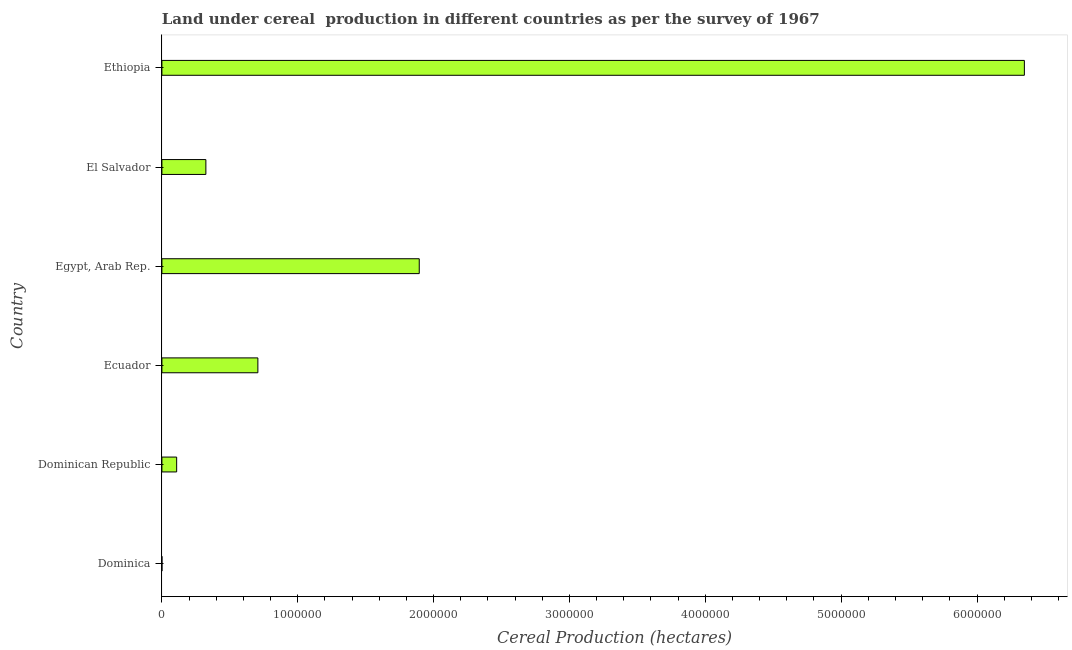What is the title of the graph?
Your answer should be compact. Land under cereal  production in different countries as per the survey of 1967. What is the label or title of the X-axis?
Offer a terse response. Cereal Production (hectares). What is the label or title of the Y-axis?
Make the answer very short. Country. What is the land under cereal production in Ethiopia?
Your response must be concise. 6.35e+06. Across all countries, what is the maximum land under cereal production?
Ensure brevity in your answer.  6.35e+06. Across all countries, what is the minimum land under cereal production?
Provide a short and direct response. 125. In which country was the land under cereal production maximum?
Offer a terse response. Ethiopia. In which country was the land under cereal production minimum?
Your answer should be very brief. Dominica. What is the sum of the land under cereal production?
Provide a succinct answer. 9.38e+06. What is the difference between the land under cereal production in Dominican Republic and El Salvador?
Ensure brevity in your answer.  -2.15e+05. What is the average land under cereal production per country?
Ensure brevity in your answer.  1.56e+06. What is the median land under cereal production?
Give a very brief answer. 5.15e+05. In how many countries, is the land under cereal production greater than 1400000 hectares?
Give a very brief answer. 2. What is the ratio of the land under cereal production in Dominica to that in Ethiopia?
Provide a succinct answer. 0. What is the difference between the highest and the second highest land under cereal production?
Keep it short and to the point. 4.45e+06. What is the difference between the highest and the lowest land under cereal production?
Your answer should be compact. 6.35e+06. In how many countries, is the land under cereal production greater than the average land under cereal production taken over all countries?
Provide a succinct answer. 2. Are all the bars in the graph horizontal?
Your answer should be very brief. Yes. What is the difference between two consecutive major ticks on the X-axis?
Provide a succinct answer. 1.00e+06. What is the Cereal Production (hectares) in Dominica?
Your answer should be very brief. 125. What is the Cereal Production (hectares) of Dominican Republic?
Offer a terse response. 1.09e+05. What is the Cereal Production (hectares) of Ecuador?
Keep it short and to the point. 7.06e+05. What is the Cereal Production (hectares) of Egypt, Arab Rep.?
Make the answer very short. 1.89e+06. What is the Cereal Production (hectares) in El Salvador?
Ensure brevity in your answer.  3.24e+05. What is the Cereal Production (hectares) in Ethiopia?
Provide a short and direct response. 6.35e+06. What is the difference between the Cereal Production (hectares) in Dominica and Dominican Republic?
Provide a short and direct response. -1.08e+05. What is the difference between the Cereal Production (hectares) in Dominica and Ecuador?
Your response must be concise. -7.06e+05. What is the difference between the Cereal Production (hectares) in Dominica and Egypt, Arab Rep.?
Ensure brevity in your answer.  -1.89e+06. What is the difference between the Cereal Production (hectares) in Dominica and El Salvador?
Make the answer very short. -3.24e+05. What is the difference between the Cereal Production (hectares) in Dominica and Ethiopia?
Give a very brief answer. -6.35e+06. What is the difference between the Cereal Production (hectares) in Dominican Republic and Ecuador?
Offer a very short reply. -5.98e+05. What is the difference between the Cereal Production (hectares) in Dominican Republic and Egypt, Arab Rep.?
Your answer should be compact. -1.79e+06. What is the difference between the Cereal Production (hectares) in Dominican Republic and El Salvador?
Provide a short and direct response. -2.15e+05. What is the difference between the Cereal Production (hectares) in Dominican Republic and Ethiopia?
Make the answer very short. -6.24e+06. What is the difference between the Cereal Production (hectares) in Ecuador and Egypt, Arab Rep.?
Offer a very short reply. -1.19e+06. What is the difference between the Cereal Production (hectares) in Ecuador and El Salvador?
Offer a very short reply. 3.83e+05. What is the difference between the Cereal Production (hectares) in Ecuador and Ethiopia?
Offer a terse response. -5.64e+06. What is the difference between the Cereal Production (hectares) in Egypt, Arab Rep. and El Salvador?
Offer a terse response. 1.57e+06. What is the difference between the Cereal Production (hectares) in Egypt, Arab Rep. and Ethiopia?
Provide a succinct answer. -4.45e+06. What is the difference between the Cereal Production (hectares) in El Salvador and Ethiopia?
Provide a short and direct response. -6.02e+06. What is the ratio of the Cereal Production (hectares) in Dominica to that in Dominican Republic?
Provide a succinct answer. 0. What is the ratio of the Cereal Production (hectares) in Dominica to that in Ecuador?
Keep it short and to the point. 0. What is the ratio of the Cereal Production (hectares) in Dominica to that in Egypt, Arab Rep.?
Ensure brevity in your answer.  0. What is the ratio of the Cereal Production (hectares) in Dominica to that in Ethiopia?
Ensure brevity in your answer.  0. What is the ratio of the Cereal Production (hectares) in Dominican Republic to that in Ecuador?
Your answer should be very brief. 0.15. What is the ratio of the Cereal Production (hectares) in Dominican Republic to that in Egypt, Arab Rep.?
Keep it short and to the point. 0.06. What is the ratio of the Cereal Production (hectares) in Dominican Republic to that in El Salvador?
Keep it short and to the point. 0.34. What is the ratio of the Cereal Production (hectares) in Dominican Republic to that in Ethiopia?
Offer a very short reply. 0.02. What is the ratio of the Cereal Production (hectares) in Ecuador to that in Egypt, Arab Rep.?
Ensure brevity in your answer.  0.37. What is the ratio of the Cereal Production (hectares) in Ecuador to that in El Salvador?
Offer a terse response. 2.18. What is the ratio of the Cereal Production (hectares) in Ecuador to that in Ethiopia?
Offer a terse response. 0.11. What is the ratio of the Cereal Production (hectares) in Egypt, Arab Rep. to that in El Salvador?
Keep it short and to the point. 5.85. What is the ratio of the Cereal Production (hectares) in Egypt, Arab Rep. to that in Ethiopia?
Make the answer very short. 0.3. What is the ratio of the Cereal Production (hectares) in El Salvador to that in Ethiopia?
Your response must be concise. 0.05. 